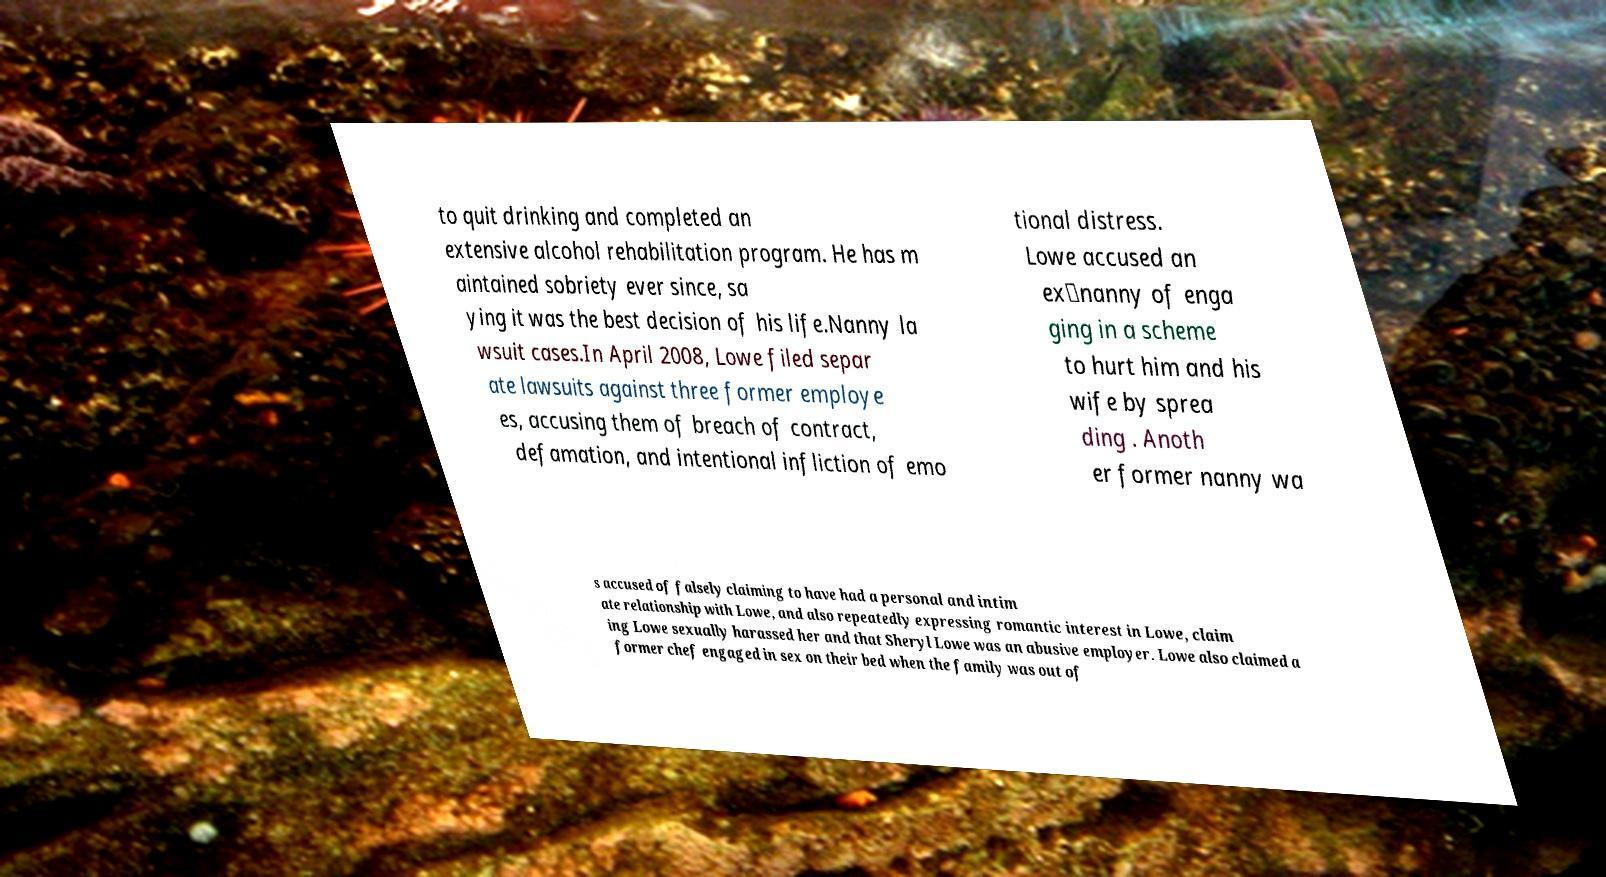Please read and relay the text visible in this image. What does it say? to quit drinking and completed an extensive alcohol rehabilitation program. He has m aintained sobriety ever since, sa ying it was the best decision of his life.Nanny la wsuit cases.In April 2008, Lowe filed separ ate lawsuits against three former employe es, accusing them of breach of contract, defamation, and intentional infliction of emo tional distress. Lowe accused an ex‑nanny of enga ging in a scheme to hurt him and his wife by sprea ding . Anoth er former nanny wa s accused of falsely claiming to have had a personal and intim ate relationship with Lowe, and also repeatedly expressing romantic interest in Lowe, claim ing Lowe sexually harassed her and that Sheryl Lowe was an abusive employer. Lowe also claimed a former chef engaged in sex on their bed when the family was out of 